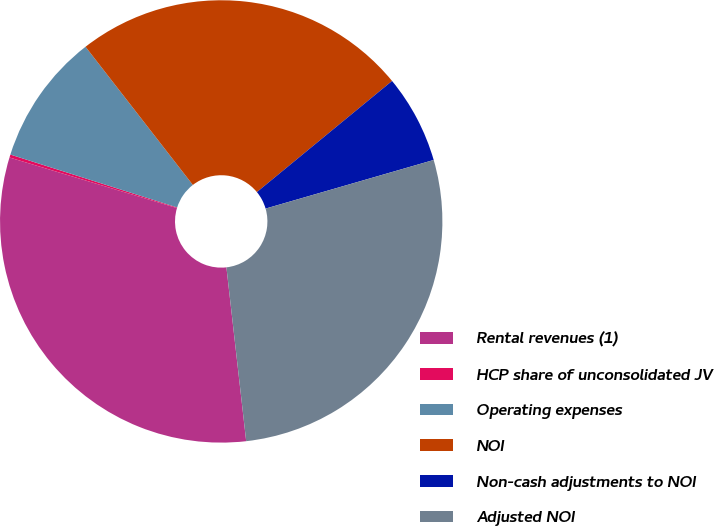Convert chart. <chart><loc_0><loc_0><loc_500><loc_500><pie_chart><fcel>Rental revenues (1)<fcel>HCP share of unconsolidated JV<fcel>Operating expenses<fcel>NOI<fcel>Non-cash adjustments to NOI<fcel>Adjusted NOI<nl><fcel>31.47%<fcel>0.22%<fcel>9.6%<fcel>24.56%<fcel>6.47%<fcel>27.68%<nl></chart> 